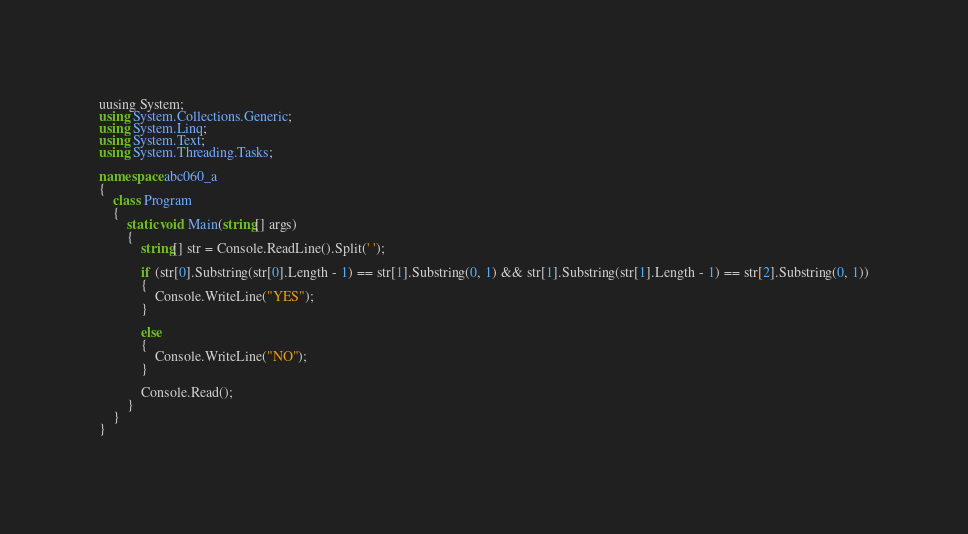Convert code to text. <code><loc_0><loc_0><loc_500><loc_500><_C#_>uusing System;
using System.Collections.Generic;
using System.Linq;
using System.Text;
using System.Threading.Tasks;
 
namespace abc060_a
{
    class Program
    {
        static void Main(string[] args)
        {
            string[] str = Console.ReadLine().Split(' ');
 
            if (str[0].Substring(str[0].Length - 1) == str[1].Substring(0, 1) && str[1].Substring(str[1].Length - 1) == str[2].Substring(0, 1))
            {
                Console.WriteLine("YES");
            }
 
            else
            {
                Console.WriteLine("NO");
            }
 
            Console.Read();
        }
    }
}
</code> 